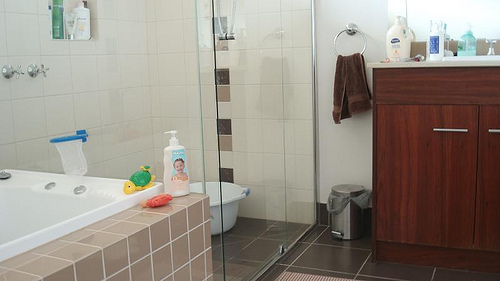Please provide a short description for this region: [0.76, 0.58, 0.84, 0.74]. Visible section of a wooden board in the bathroom. 